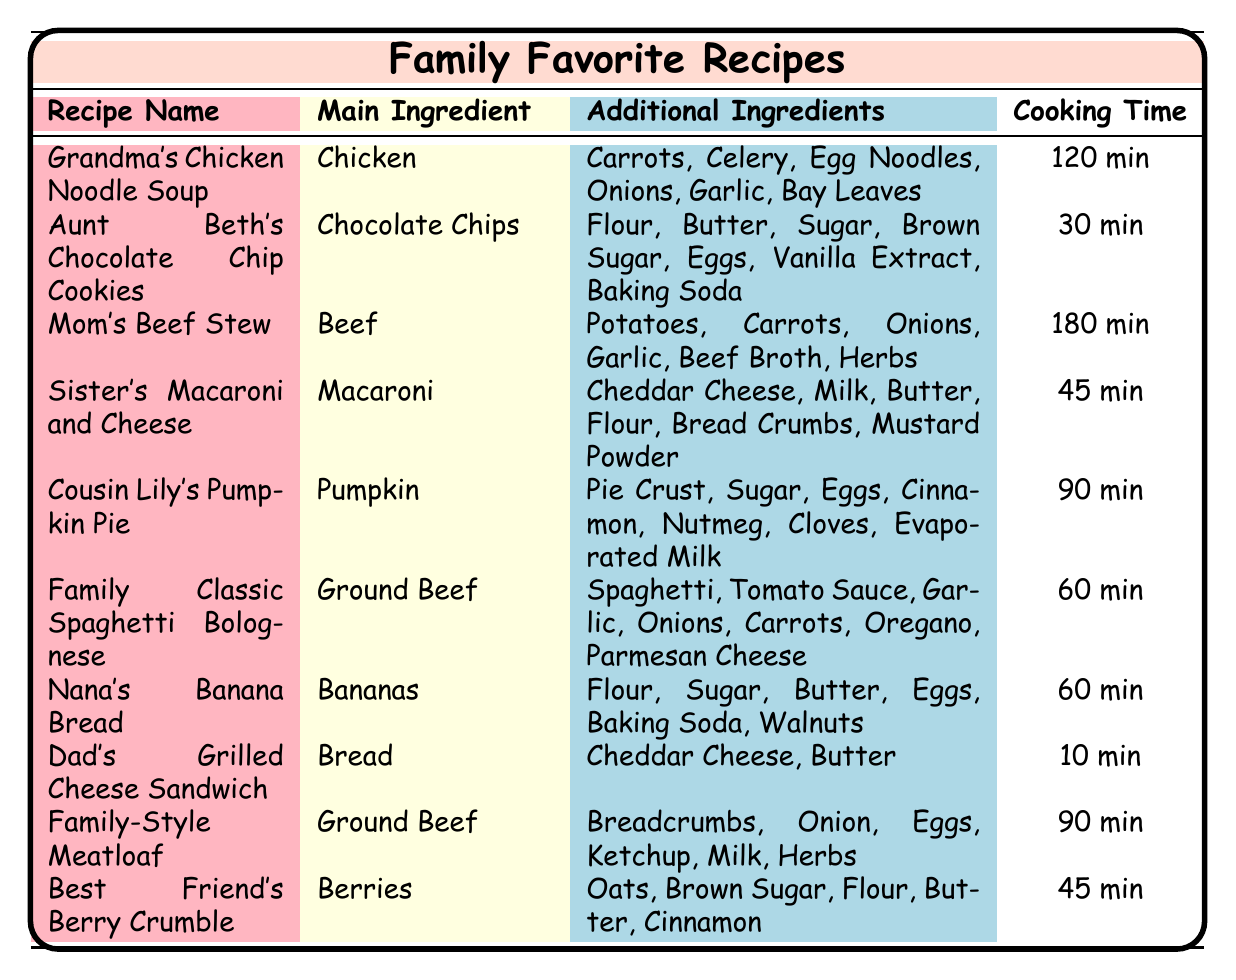What is the cooking time for Aunt Beth's Chocolate Chip Cookies? From the table, I locate the row corresponding to Aunt Beth's Chocolate Chip Cookies and read the cooking time column, which states 30 minutes.
Answer: 30 min How many additional ingredients are in Grandma's Chicken Noodle Soup? I find the row for Grandma's Chicken Noodle Soup, which lists 6 additional ingredients in the additional ingredients column.
Answer: 6 Which recipe has the longest cooking time? The recipe with the longest cooking time can be identified by comparing the cooking time values in all rows. Mom's Beef Stew has the cooking time of 180 minutes, which is the highest.
Answer: Mom's Beef Stew Is Dad's Grilled Cheese Sandwich made with eggs? Checking the additional ingredients for Dad's Grilled Cheese Sandwich, I see it contains only Cheddar Cheese and Butter. Therefore, it does not include eggs.
Answer: No What is the average cooking time of all recipes containing Ground Beef? First, I identify the recipes with Ground Beef: Family Classic Spaghetti Bolognese (60 min) and Family-Style Meatloaf (90 min). I sum the cooking times: 60 + 90 = 150 minutes. Then, I divide by the number of recipes (2): 150/2 = 75 minutes.
Answer: 75 min Which recipe uses the main ingredient Pumpkin? I refer to the main ingredient column and find Cousin Lily's Pumpkin Pie, which has pumpkin listed as its main ingredient.
Answer: Cousin Lily's Pumpkin Pie Are there any recipes that take less than 30 minutes to cook? I review the cooking times for all recipes. The shortest cooking time is for Dad's Grilled Cheese Sandwich at 10 minutes, which is less than 30 minutes.
Answer: Yes What are the main ingredients of the recipes that take 90 minutes to cook? I locate the recipes with 90 minutes cooking time which are Cousin Lily's Pumpkin Pie and Family-Style Meatloaf. The main ingredients are Pumpkin for the first and Ground Beef for the second. Thus, the list is Pumpkin and Ground Beef.
Answer: Pumpkin, Ground Beef 